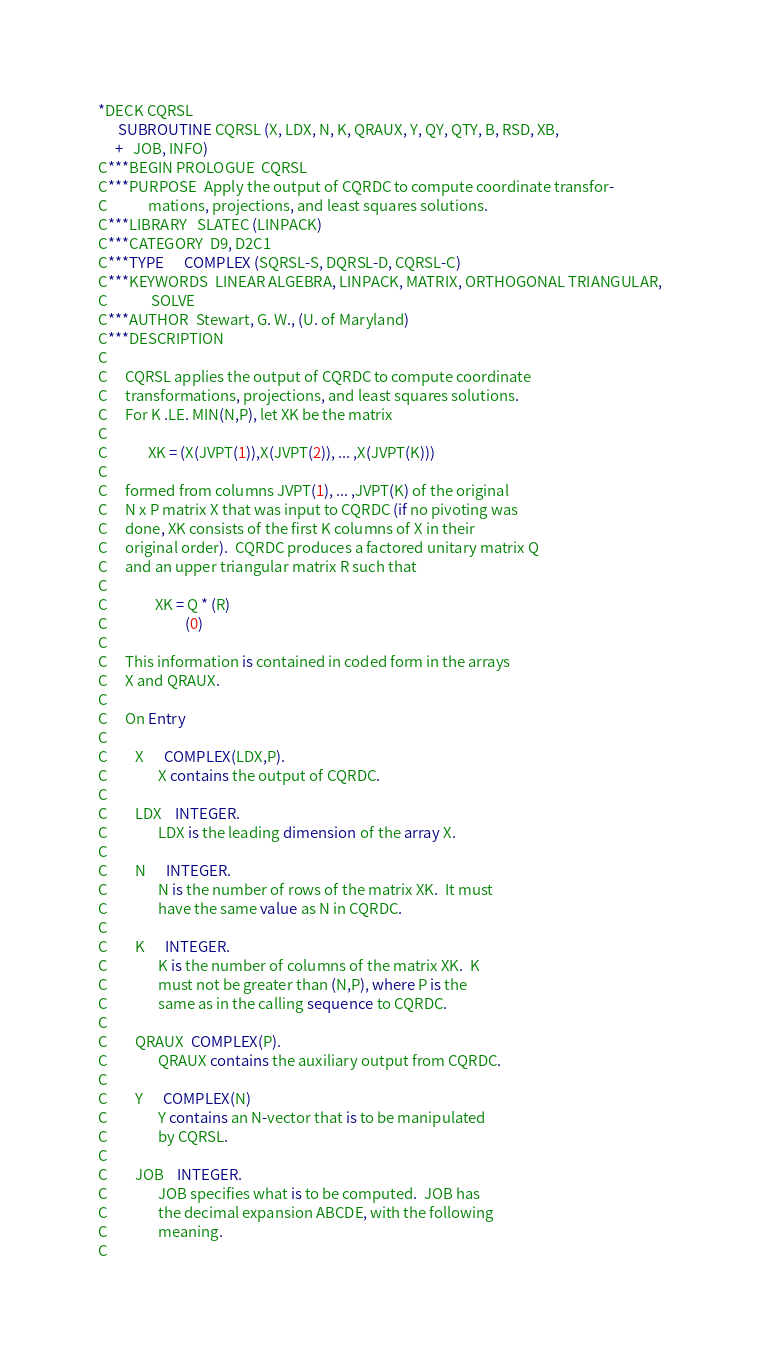<code> <loc_0><loc_0><loc_500><loc_500><_FORTRAN_>*DECK CQRSL
      SUBROUTINE CQRSL (X, LDX, N, K, QRAUX, Y, QY, QTY, B, RSD, XB,
     +   JOB, INFO)
C***BEGIN PROLOGUE  CQRSL
C***PURPOSE  Apply the output of CQRDC to compute coordinate transfor-
C            mations, projections, and least squares solutions.
C***LIBRARY   SLATEC (LINPACK)
C***CATEGORY  D9, D2C1
C***TYPE      COMPLEX (SQRSL-S, DQRSL-D, CQRSL-C)
C***KEYWORDS  LINEAR ALGEBRA, LINPACK, MATRIX, ORTHOGONAL TRIANGULAR,
C             SOLVE
C***AUTHOR  Stewart, G. W., (U. of Maryland)
C***DESCRIPTION
C
C     CQRSL applies the output of CQRDC to compute coordinate
C     transformations, projections, and least squares solutions.
C     For K .LE. MIN(N,P), let XK be the matrix
C
C            XK = (X(JVPT(1)),X(JVPT(2)), ... ,X(JVPT(K)))
C
C     formed from columns JVPT(1), ... ,JVPT(K) of the original
C     N x P matrix X that was input to CQRDC (if no pivoting was
C     done, XK consists of the first K columns of X in their
C     original order).  CQRDC produces a factored unitary matrix Q
C     and an upper triangular matrix R such that
C
C              XK = Q * (R)
C                       (0)
C
C     This information is contained in coded form in the arrays
C     X and QRAUX.
C
C     On Entry
C
C        X      COMPLEX(LDX,P).
C               X contains the output of CQRDC.
C
C        LDX    INTEGER.
C               LDX is the leading dimension of the array X.
C
C        N      INTEGER.
C               N is the number of rows of the matrix XK.  It must
C               have the same value as N in CQRDC.
C
C        K      INTEGER.
C               K is the number of columns of the matrix XK.  K
C               must not be greater than (N,P), where P is the
C               same as in the calling sequence to CQRDC.
C
C        QRAUX  COMPLEX(P).
C               QRAUX contains the auxiliary output from CQRDC.
C
C        Y      COMPLEX(N)
C               Y contains an N-vector that is to be manipulated
C               by CQRSL.
C
C        JOB    INTEGER.
C               JOB specifies what is to be computed.  JOB has
C               the decimal expansion ABCDE, with the following
C               meaning.
C</code> 